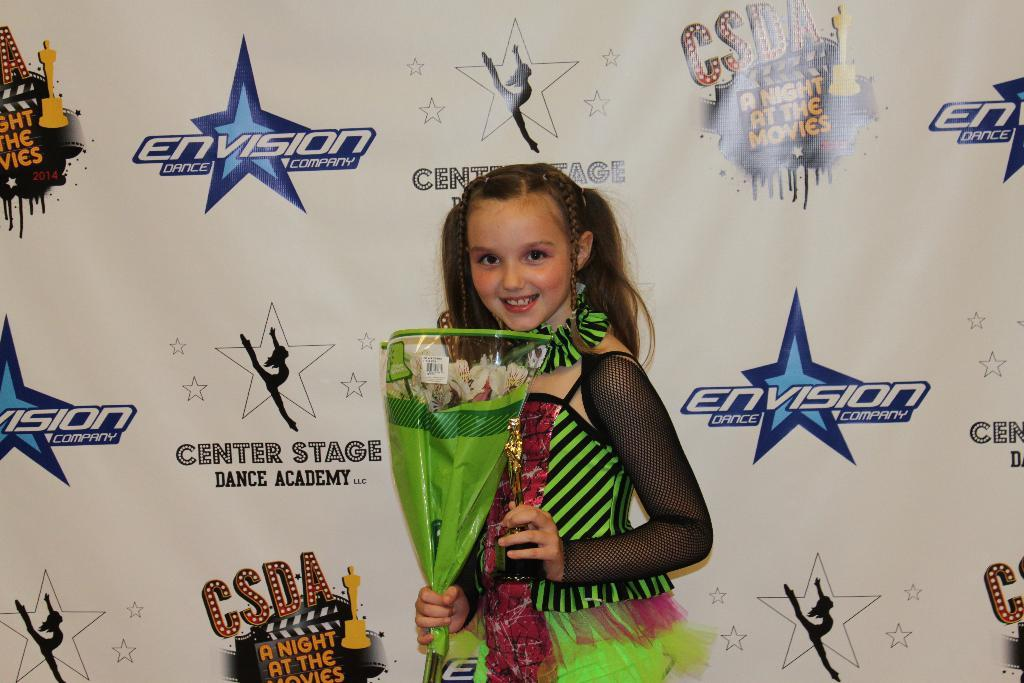What is the main subject of the image? The main subject of the image is a kid. What is the kid doing in the image? The kid is holding objects in their hands. What can be seen in the background of the image? There is a wall in the background of the image. Is there any text visible in the image? Yes, there is text written on the wall. What type of steel is used to make the hair visible in the image? There is no steel or hair present in the image. How is the wax being used in the image? There is no wax present in the image. 